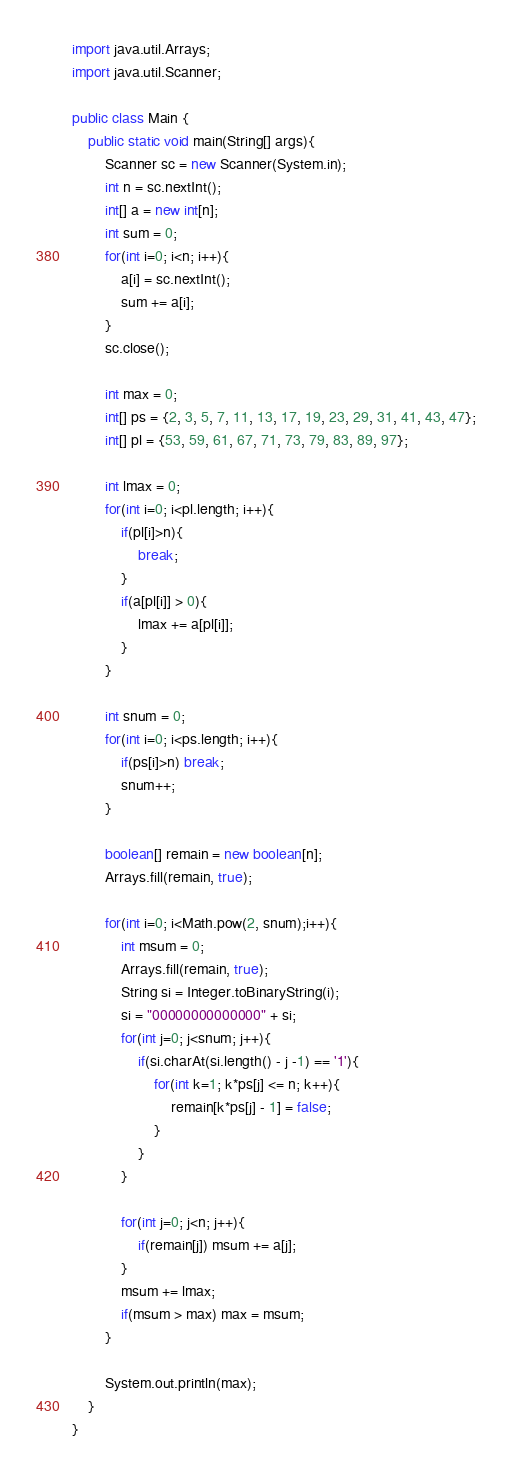Convert code to text. <code><loc_0><loc_0><loc_500><loc_500><_Java_>import java.util.Arrays;
import java.util.Scanner;

public class Main {
	public static void main(String[] args){
		Scanner sc = new Scanner(System.in);
		int n = sc.nextInt();
		int[] a = new int[n];
		int sum = 0;
		for(int i=0; i<n; i++){
			a[i] = sc.nextInt();
			sum += a[i];
		}
		sc.close();
		
		int max = 0;
		int[] ps = {2, 3, 5, 7, 11, 13, 17, 19, 23, 29, 31, 41, 43, 47};
		int[] pl = {53, 59, 61, 67, 71, 73, 79, 83, 89, 97};
		
		int lmax = 0;
		for(int i=0; i<pl.length; i++){
			if(pl[i]>n){
				break;
			}
			if(a[pl[i]] > 0){
				lmax += a[pl[i]];
			}
		}
		
		int snum = 0;
		for(int i=0; i<ps.length; i++){
			if(ps[i]>n) break;
			snum++;
		}
		
		boolean[] remain = new boolean[n];
		Arrays.fill(remain, true);
		
		for(int i=0; i<Math.pow(2, snum);i++){
			int msum = 0;
			Arrays.fill(remain, true);
			String si = Integer.toBinaryString(i);
			si = "00000000000000" + si;
			for(int j=0; j<snum; j++){
				if(si.charAt(si.length() - j -1) == '1'){
					for(int k=1; k*ps[j] <= n; k++){
						remain[k*ps[j] - 1] = false;
					}
				}
			}
			
			for(int j=0; j<n; j++){
				if(remain[j]) msum += a[j];
			}
			msum += lmax;
			if(msum > max) max = msum;
		}
		
		System.out.println(max);
	}
}
</code> 